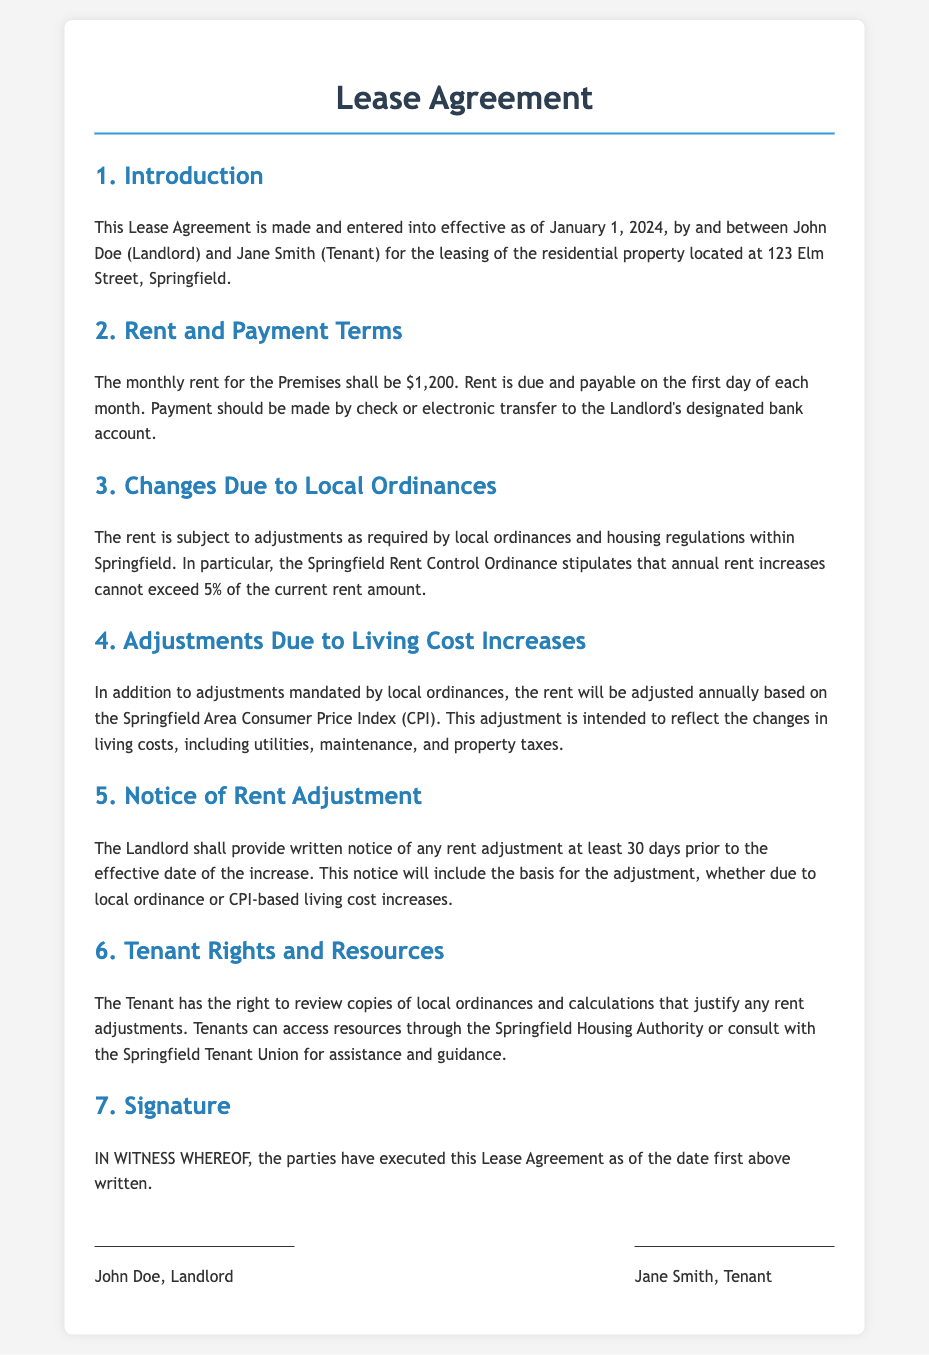What is the effective date of the Lease Agreement? The effective date is mentioned in the introduction section of the document.
Answer: January 1, 2024 What is the monthly rent for the premises? The document states the monthly rent amount in the rent and payment terms section.
Answer: $1,200 What is the maximum percentage of rent increase allowed by the Springfield Rent Control Ordinance? This is specified in the section about changes due to local ordinances.
Answer: 5% How much notice must the landlord provide before a rent adjustment takes effect? The notice period is stated in the section regarding notice of rent adjustment.
Answer: 30 days Which index is used to adjust the rent based on living cost increases? This is indicated in the section discussing adjustments due to living cost increases.
Answer: Springfield Area Consumer Price Index (CPI) What rights does the tenant have regarding rent adjustment calculations? The rights are outlined in the section about tenant rights and resources.
Answer: Review copies of local ordinances and calculations Who are the parties involved in the Lease Agreement? The parties are mentioned in the introduction section, where roles are defined.
Answer: John Doe and Jane Smith What will the landlord provide in written notice of a rent adjustment? The content of the written notice is detailed in the notice of rent adjustment section.
Answer: Basis for the adjustment 